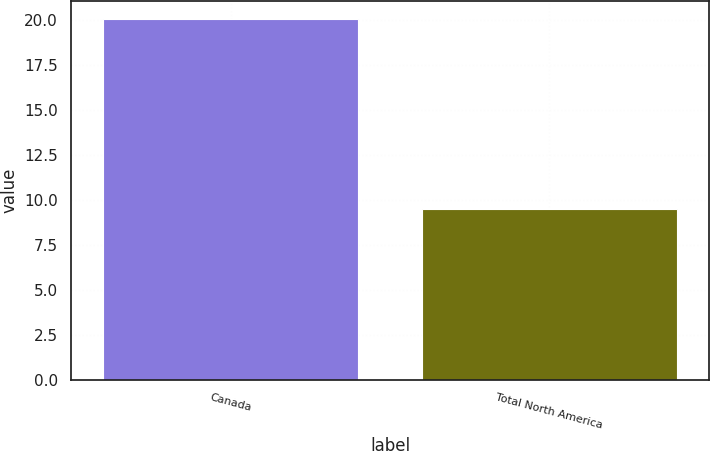Convert chart. <chart><loc_0><loc_0><loc_500><loc_500><bar_chart><fcel>Canada<fcel>Total North America<nl><fcel>20.1<fcel>9.49<nl></chart> 